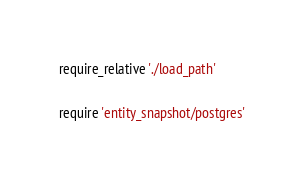Convert code to text. <code><loc_0><loc_0><loc_500><loc_500><_Ruby_>require_relative './load_path'

require 'entity_snapshot/postgres'
</code> 